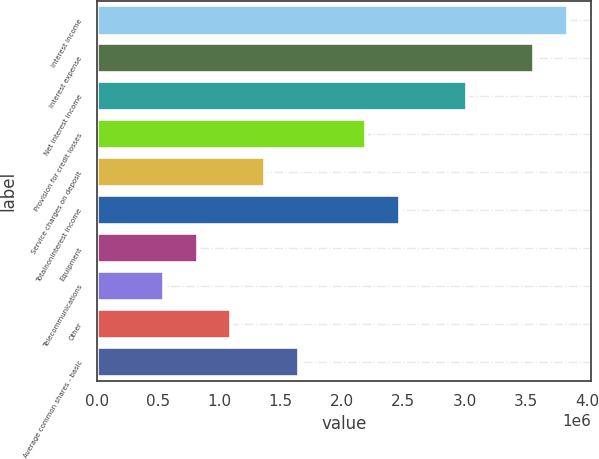<chart> <loc_0><loc_0><loc_500><loc_500><bar_chart><fcel>Interest income<fcel>Interest expense<fcel>Net interest income<fcel>Provision for credit losses<fcel>Service charges on deposit<fcel>Totalnoninterest income<fcel>Equipment<fcel>Telecommunications<fcel>Other<fcel>Average common shares - basic<nl><fcel>3.84015e+06<fcel>3.56585e+06<fcel>3.01726e+06<fcel>2.19437e+06<fcel>1.37148e+06<fcel>2.46867e+06<fcel>822890<fcel>548593<fcel>1.09719e+06<fcel>1.64578e+06<nl></chart> 